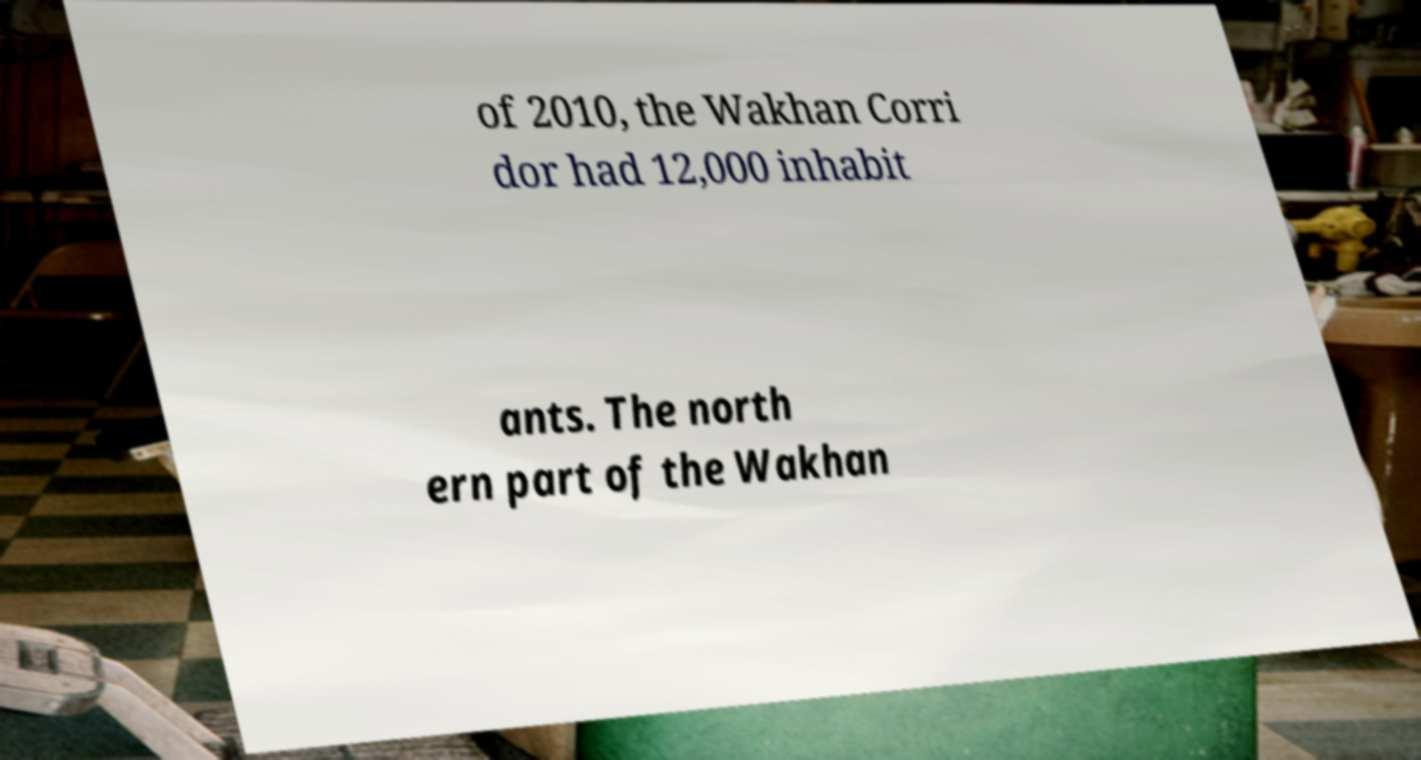Can you accurately transcribe the text from the provided image for me? of 2010, the Wakhan Corri dor had 12,000 inhabit ants. The north ern part of the Wakhan 